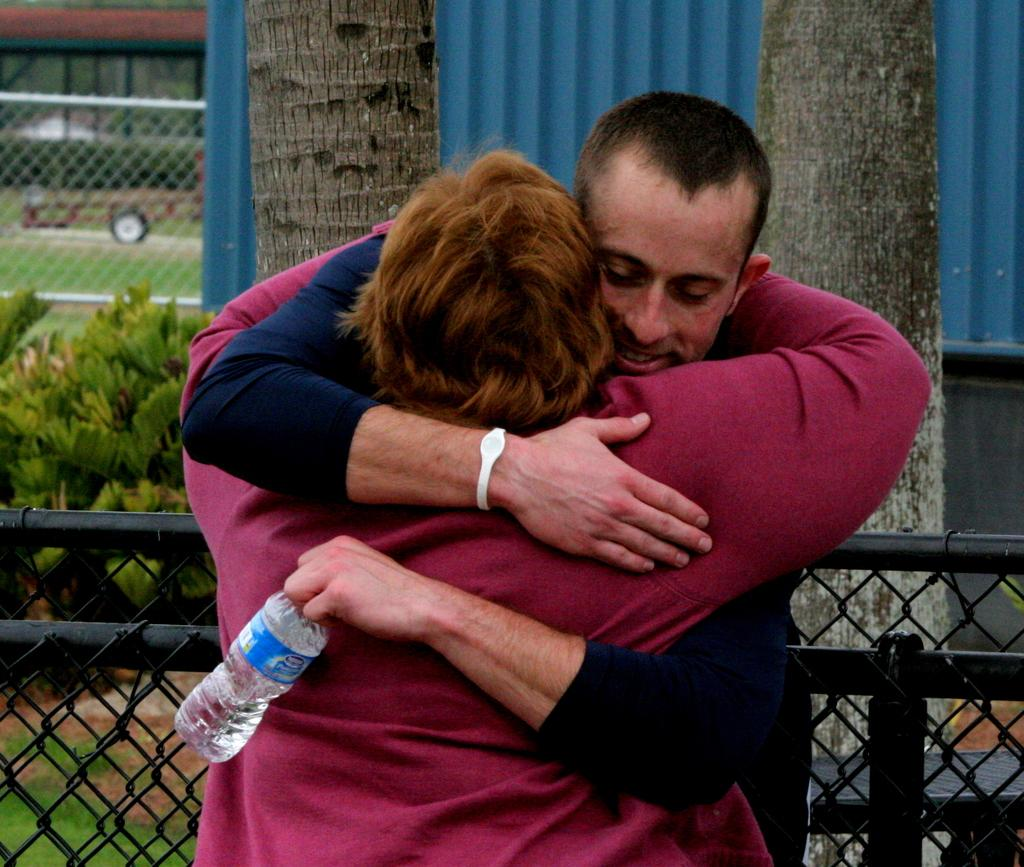How many people are in the image? There are two persons in the image. What are the two persons doing? The two persons are hugging each other. What is the man holding in the image? The man is holding a bottle. Can you describe the fence in the image? The fence in the image is black in color. What type of natural environment is visible in the image? There is grass visible in the image, and there are plants as well. What type of van is parked near the fence in the image? There is no van present in the image; it only features a fence, grass, plants, and two persons hugging each other. 